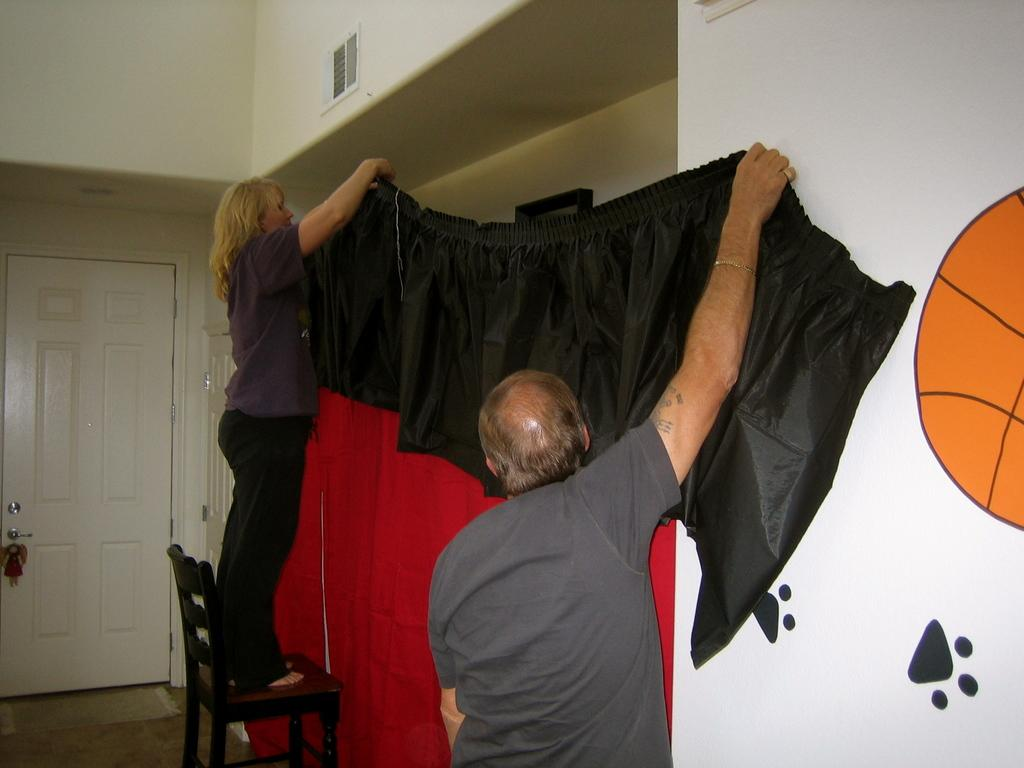How many people are in the image? There are two people in the image, a man and a woman. What are the man and woman doing in the image? Both the man and woman are standing and holding a cloth. Is there anyone else in the image besides the man and woman? No, there is only one woman standing on a chair. What type of collar can be seen on the horn in the image? There is no collar or horn present in the image. 